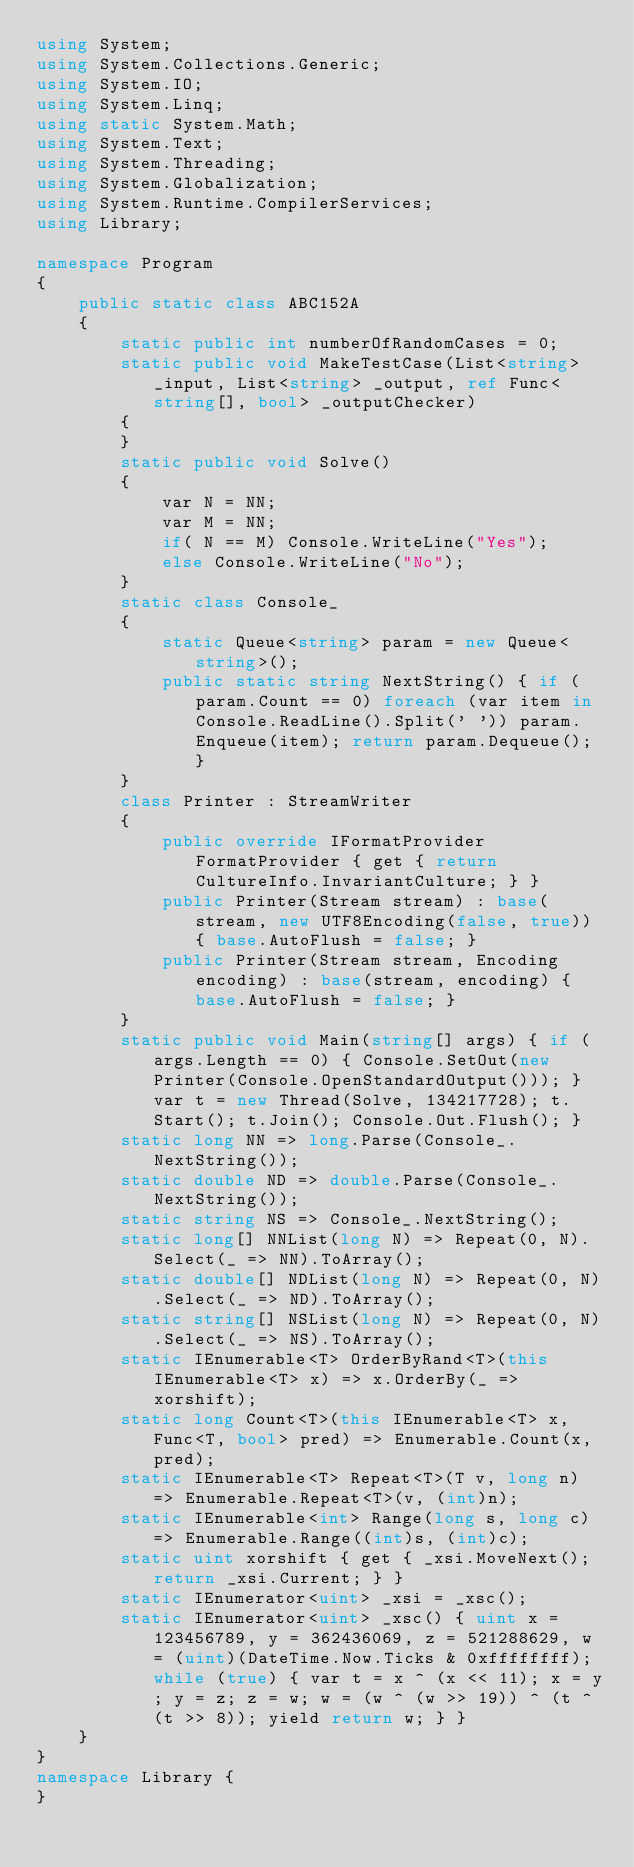Convert code to text. <code><loc_0><loc_0><loc_500><loc_500><_C#_>using System;
using System.Collections.Generic;
using System.IO;
using System.Linq;
using static System.Math;
using System.Text;
using System.Threading;
using System.Globalization;
using System.Runtime.CompilerServices;
using Library;

namespace Program
{
    public static class ABC152A
    {
        static public int numberOfRandomCases = 0;
        static public void MakeTestCase(List<string> _input, List<string> _output, ref Func<string[], bool> _outputChecker)
        {
        }
        static public void Solve()
        {
            var N = NN;
            var M = NN;
            if( N == M) Console.WriteLine("Yes");
            else Console.WriteLine("No");
        }
        static class Console_
        {
            static Queue<string> param = new Queue<string>();
            public static string NextString() { if (param.Count == 0) foreach (var item in Console.ReadLine().Split(' ')) param.Enqueue(item); return param.Dequeue(); }
        }
        class Printer : StreamWriter
        {
            public override IFormatProvider FormatProvider { get { return CultureInfo.InvariantCulture; } }
            public Printer(Stream stream) : base(stream, new UTF8Encoding(false, true)) { base.AutoFlush = false; }
            public Printer(Stream stream, Encoding encoding) : base(stream, encoding) { base.AutoFlush = false; }
        }
        static public void Main(string[] args) { if (args.Length == 0) { Console.SetOut(new Printer(Console.OpenStandardOutput())); } var t = new Thread(Solve, 134217728); t.Start(); t.Join(); Console.Out.Flush(); }
        static long NN => long.Parse(Console_.NextString());
        static double ND => double.Parse(Console_.NextString());
        static string NS => Console_.NextString();
        static long[] NNList(long N) => Repeat(0, N).Select(_ => NN).ToArray();
        static double[] NDList(long N) => Repeat(0, N).Select(_ => ND).ToArray();
        static string[] NSList(long N) => Repeat(0, N).Select(_ => NS).ToArray();
        static IEnumerable<T> OrderByRand<T>(this IEnumerable<T> x) => x.OrderBy(_ => xorshift);
        static long Count<T>(this IEnumerable<T> x, Func<T, bool> pred) => Enumerable.Count(x, pred);
        static IEnumerable<T> Repeat<T>(T v, long n) => Enumerable.Repeat<T>(v, (int)n);
        static IEnumerable<int> Range(long s, long c) => Enumerable.Range((int)s, (int)c);
        static uint xorshift { get { _xsi.MoveNext(); return _xsi.Current; } }
        static IEnumerator<uint> _xsi = _xsc();
        static IEnumerator<uint> _xsc() { uint x = 123456789, y = 362436069, z = 521288629, w = (uint)(DateTime.Now.Ticks & 0xffffffff); while (true) { var t = x ^ (x << 11); x = y; y = z; z = w; w = (w ^ (w >> 19)) ^ (t ^ (t >> 8)); yield return w; } }
    }
}
namespace Library {
}
</code> 